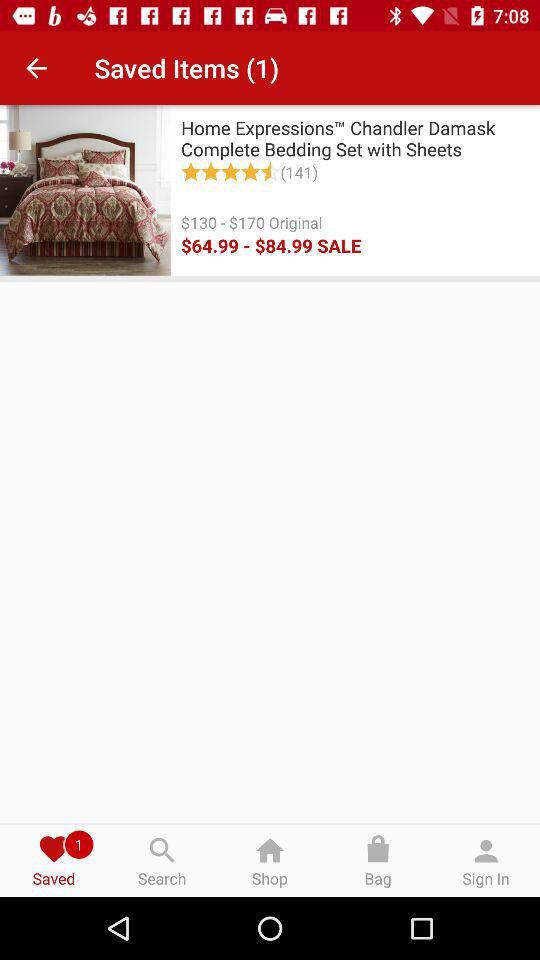What is the count of saved items? The count is 1. 